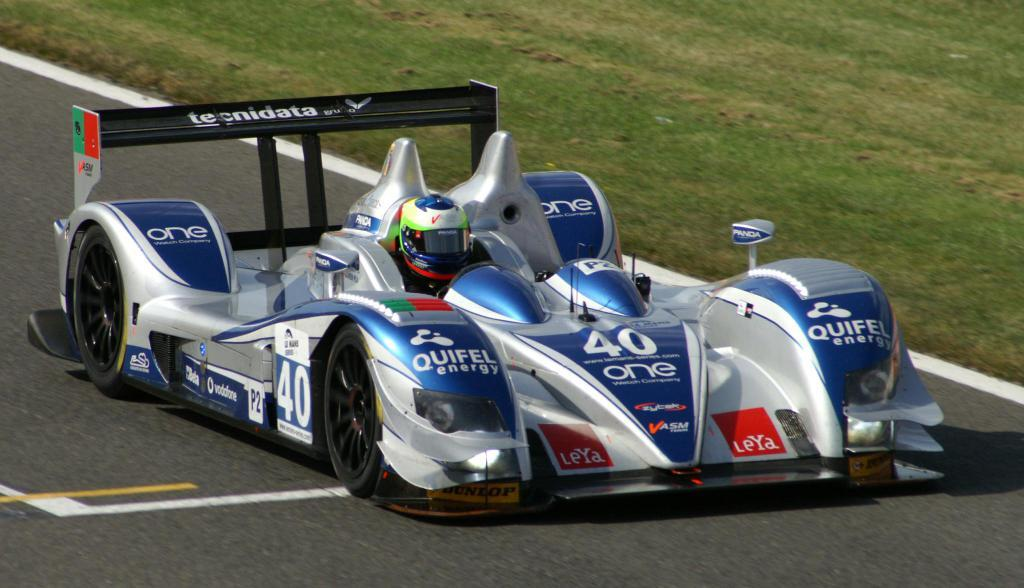What is on the road in the image? There is a vehicle on the road in the image. Who or what is on the vehicle? There is a person on the vehicle. What can be seen in the background of the image? There is grass visible in the background of the image. What type of baseball selection is being made in the image? There is no baseball or selection present in the image. 